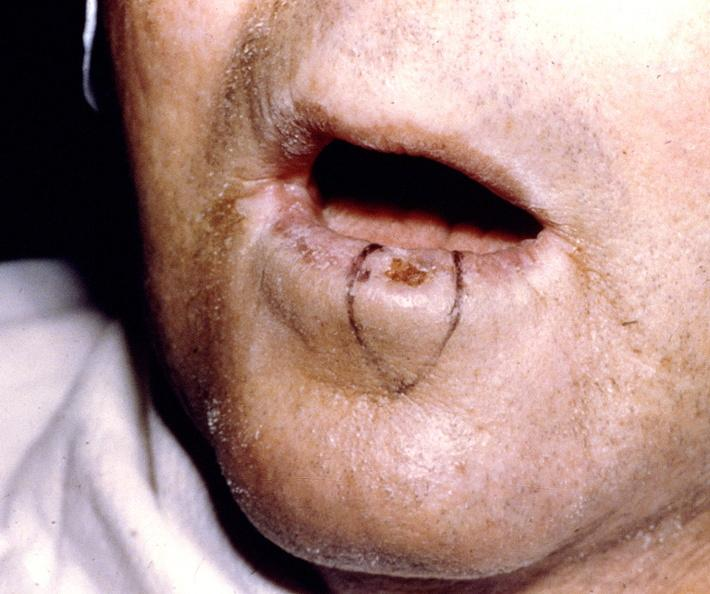where does this belong to?
Answer the question using a single word or phrase. Gastrointestinal system 